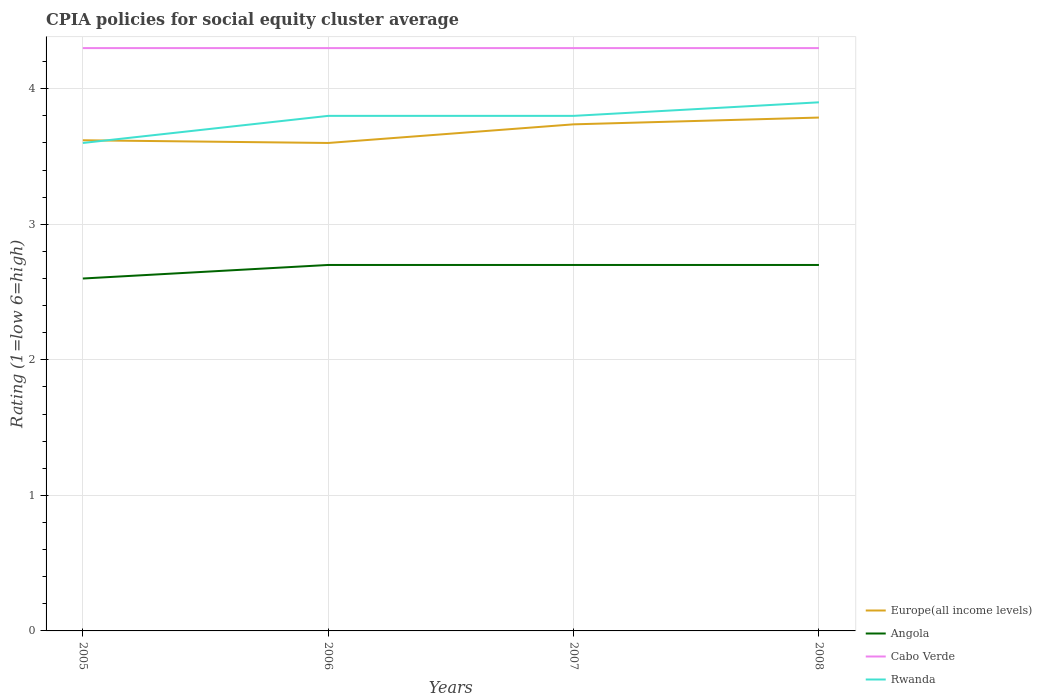How many different coloured lines are there?
Offer a terse response. 4. Is the number of lines equal to the number of legend labels?
Your response must be concise. Yes. Across all years, what is the maximum CPIA rating in Rwanda?
Make the answer very short. 3.6. What is the total CPIA rating in Rwanda in the graph?
Make the answer very short. -0.1. What is the difference between the highest and the lowest CPIA rating in Europe(all income levels)?
Offer a very short reply. 2. Is the CPIA rating in Angola strictly greater than the CPIA rating in Cabo Verde over the years?
Offer a very short reply. Yes. How many lines are there?
Provide a short and direct response. 4. Does the graph contain grids?
Provide a succinct answer. Yes. Where does the legend appear in the graph?
Give a very brief answer. Bottom right. How many legend labels are there?
Keep it short and to the point. 4. How are the legend labels stacked?
Your answer should be compact. Vertical. What is the title of the graph?
Provide a short and direct response. CPIA policies for social equity cluster average. Does "Middle East & North Africa (developing only)" appear as one of the legend labels in the graph?
Offer a terse response. No. What is the label or title of the X-axis?
Offer a very short reply. Years. What is the Rating (1=low 6=high) of Europe(all income levels) in 2005?
Your response must be concise. 3.62. What is the Rating (1=low 6=high) of Rwanda in 2005?
Ensure brevity in your answer.  3.6. What is the Rating (1=low 6=high) of Europe(all income levels) in 2006?
Your answer should be very brief. 3.6. What is the Rating (1=low 6=high) in Angola in 2006?
Provide a short and direct response. 2.7. What is the Rating (1=low 6=high) of Cabo Verde in 2006?
Your answer should be very brief. 4.3. What is the Rating (1=low 6=high) of Europe(all income levels) in 2007?
Keep it short and to the point. 3.74. What is the Rating (1=low 6=high) of Europe(all income levels) in 2008?
Offer a very short reply. 3.79. What is the Rating (1=low 6=high) in Cabo Verde in 2008?
Provide a short and direct response. 4.3. What is the Rating (1=low 6=high) in Rwanda in 2008?
Make the answer very short. 3.9. Across all years, what is the maximum Rating (1=low 6=high) of Europe(all income levels)?
Ensure brevity in your answer.  3.79. Across all years, what is the maximum Rating (1=low 6=high) of Angola?
Your response must be concise. 2.7. Across all years, what is the maximum Rating (1=low 6=high) in Rwanda?
Make the answer very short. 3.9. Across all years, what is the minimum Rating (1=low 6=high) of Europe(all income levels)?
Provide a short and direct response. 3.6. Across all years, what is the minimum Rating (1=low 6=high) in Cabo Verde?
Make the answer very short. 4.3. What is the total Rating (1=low 6=high) in Europe(all income levels) in the graph?
Your answer should be very brief. 14.74. What is the total Rating (1=low 6=high) of Cabo Verde in the graph?
Ensure brevity in your answer.  17.2. What is the total Rating (1=low 6=high) of Rwanda in the graph?
Keep it short and to the point. 15.1. What is the difference between the Rating (1=low 6=high) of Europe(all income levels) in 2005 and that in 2006?
Your answer should be very brief. 0.02. What is the difference between the Rating (1=low 6=high) of Angola in 2005 and that in 2006?
Give a very brief answer. -0.1. What is the difference between the Rating (1=low 6=high) in Cabo Verde in 2005 and that in 2006?
Give a very brief answer. 0. What is the difference between the Rating (1=low 6=high) in Europe(all income levels) in 2005 and that in 2007?
Offer a terse response. -0.12. What is the difference between the Rating (1=low 6=high) of Europe(all income levels) in 2005 and that in 2008?
Offer a very short reply. -0.17. What is the difference between the Rating (1=low 6=high) of Cabo Verde in 2005 and that in 2008?
Provide a succinct answer. 0. What is the difference between the Rating (1=low 6=high) of Rwanda in 2005 and that in 2008?
Provide a succinct answer. -0.3. What is the difference between the Rating (1=low 6=high) of Europe(all income levels) in 2006 and that in 2007?
Your answer should be compact. -0.14. What is the difference between the Rating (1=low 6=high) of Rwanda in 2006 and that in 2007?
Provide a short and direct response. 0. What is the difference between the Rating (1=low 6=high) of Europe(all income levels) in 2006 and that in 2008?
Your response must be concise. -0.19. What is the difference between the Rating (1=low 6=high) in Angola in 2006 and that in 2008?
Provide a short and direct response. 0. What is the difference between the Rating (1=low 6=high) in Cabo Verde in 2006 and that in 2008?
Offer a terse response. 0. What is the difference between the Rating (1=low 6=high) in Rwanda in 2006 and that in 2008?
Offer a terse response. -0.1. What is the difference between the Rating (1=low 6=high) of Europe(all income levels) in 2007 and that in 2008?
Your response must be concise. -0.05. What is the difference between the Rating (1=low 6=high) in Cabo Verde in 2007 and that in 2008?
Ensure brevity in your answer.  0. What is the difference between the Rating (1=low 6=high) of Rwanda in 2007 and that in 2008?
Make the answer very short. -0.1. What is the difference between the Rating (1=low 6=high) in Europe(all income levels) in 2005 and the Rating (1=low 6=high) in Cabo Verde in 2006?
Offer a very short reply. -0.68. What is the difference between the Rating (1=low 6=high) in Europe(all income levels) in 2005 and the Rating (1=low 6=high) in Rwanda in 2006?
Offer a terse response. -0.18. What is the difference between the Rating (1=low 6=high) of Angola in 2005 and the Rating (1=low 6=high) of Rwanda in 2006?
Provide a short and direct response. -1.2. What is the difference between the Rating (1=low 6=high) of Europe(all income levels) in 2005 and the Rating (1=low 6=high) of Cabo Verde in 2007?
Make the answer very short. -0.68. What is the difference between the Rating (1=low 6=high) in Europe(all income levels) in 2005 and the Rating (1=low 6=high) in Rwanda in 2007?
Provide a short and direct response. -0.18. What is the difference between the Rating (1=low 6=high) of Angola in 2005 and the Rating (1=low 6=high) of Rwanda in 2007?
Your response must be concise. -1.2. What is the difference between the Rating (1=low 6=high) of Europe(all income levels) in 2005 and the Rating (1=low 6=high) of Cabo Verde in 2008?
Give a very brief answer. -0.68. What is the difference between the Rating (1=low 6=high) in Europe(all income levels) in 2005 and the Rating (1=low 6=high) in Rwanda in 2008?
Your answer should be very brief. -0.28. What is the difference between the Rating (1=low 6=high) of Cabo Verde in 2005 and the Rating (1=low 6=high) of Rwanda in 2008?
Provide a short and direct response. 0.4. What is the difference between the Rating (1=low 6=high) of Europe(all income levels) in 2006 and the Rating (1=low 6=high) of Angola in 2007?
Offer a terse response. 0.9. What is the difference between the Rating (1=low 6=high) in Europe(all income levels) in 2006 and the Rating (1=low 6=high) in Cabo Verde in 2007?
Give a very brief answer. -0.7. What is the difference between the Rating (1=low 6=high) in Europe(all income levels) in 2006 and the Rating (1=low 6=high) in Rwanda in 2007?
Your response must be concise. -0.2. What is the difference between the Rating (1=low 6=high) of Angola in 2006 and the Rating (1=low 6=high) of Cabo Verde in 2007?
Provide a succinct answer. -1.6. What is the difference between the Rating (1=low 6=high) of Cabo Verde in 2006 and the Rating (1=low 6=high) of Rwanda in 2007?
Give a very brief answer. 0.5. What is the difference between the Rating (1=low 6=high) of Europe(all income levels) in 2006 and the Rating (1=low 6=high) of Angola in 2008?
Your response must be concise. 0.9. What is the difference between the Rating (1=low 6=high) of Europe(all income levels) in 2006 and the Rating (1=low 6=high) of Cabo Verde in 2008?
Keep it short and to the point. -0.7. What is the difference between the Rating (1=low 6=high) of Angola in 2006 and the Rating (1=low 6=high) of Cabo Verde in 2008?
Keep it short and to the point. -1.6. What is the difference between the Rating (1=low 6=high) in Angola in 2006 and the Rating (1=low 6=high) in Rwanda in 2008?
Give a very brief answer. -1.2. What is the difference between the Rating (1=low 6=high) of Europe(all income levels) in 2007 and the Rating (1=low 6=high) of Angola in 2008?
Your response must be concise. 1.04. What is the difference between the Rating (1=low 6=high) in Europe(all income levels) in 2007 and the Rating (1=low 6=high) in Cabo Verde in 2008?
Offer a very short reply. -0.56. What is the difference between the Rating (1=low 6=high) of Europe(all income levels) in 2007 and the Rating (1=low 6=high) of Rwanda in 2008?
Provide a succinct answer. -0.16. What is the difference between the Rating (1=low 6=high) of Cabo Verde in 2007 and the Rating (1=low 6=high) of Rwanda in 2008?
Provide a short and direct response. 0.4. What is the average Rating (1=low 6=high) of Europe(all income levels) per year?
Ensure brevity in your answer.  3.69. What is the average Rating (1=low 6=high) in Angola per year?
Your answer should be compact. 2.67. What is the average Rating (1=low 6=high) of Rwanda per year?
Your answer should be very brief. 3.77. In the year 2005, what is the difference between the Rating (1=low 6=high) in Europe(all income levels) and Rating (1=low 6=high) in Angola?
Give a very brief answer. 1.02. In the year 2005, what is the difference between the Rating (1=low 6=high) in Europe(all income levels) and Rating (1=low 6=high) in Cabo Verde?
Offer a very short reply. -0.68. In the year 2005, what is the difference between the Rating (1=low 6=high) in Angola and Rating (1=low 6=high) in Cabo Verde?
Your response must be concise. -1.7. In the year 2005, what is the difference between the Rating (1=low 6=high) of Cabo Verde and Rating (1=low 6=high) of Rwanda?
Give a very brief answer. 0.7. In the year 2006, what is the difference between the Rating (1=low 6=high) of Europe(all income levels) and Rating (1=low 6=high) of Angola?
Provide a succinct answer. 0.9. In the year 2006, what is the difference between the Rating (1=low 6=high) in Europe(all income levels) and Rating (1=low 6=high) in Rwanda?
Your answer should be very brief. -0.2. In the year 2006, what is the difference between the Rating (1=low 6=high) in Angola and Rating (1=low 6=high) in Rwanda?
Offer a terse response. -1.1. In the year 2006, what is the difference between the Rating (1=low 6=high) of Cabo Verde and Rating (1=low 6=high) of Rwanda?
Ensure brevity in your answer.  0.5. In the year 2007, what is the difference between the Rating (1=low 6=high) of Europe(all income levels) and Rating (1=low 6=high) of Angola?
Offer a very short reply. 1.04. In the year 2007, what is the difference between the Rating (1=low 6=high) of Europe(all income levels) and Rating (1=low 6=high) of Cabo Verde?
Provide a succinct answer. -0.56. In the year 2007, what is the difference between the Rating (1=low 6=high) in Europe(all income levels) and Rating (1=low 6=high) in Rwanda?
Provide a succinct answer. -0.06. In the year 2008, what is the difference between the Rating (1=low 6=high) of Europe(all income levels) and Rating (1=low 6=high) of Angola?
Your answer should be very brief. 1.09. In the year 2008, what is the difference between the Rating (1=low 6=high) in Europe(all income levels) and Rating (1=low 6=high) in Cabo Verde?
Keep it short and to the point. -0.51. In the year 2008, what is the difference between the Rating (1=low 6=high) in Europe(all income levels) and Rating (1=low 6=high) in Rwanda?
Provide a short and direct response. -0.11. What is the ratio of the Rating (1=low 6=high) in Europe(all income levels) in 2005 to that in 2006?
Keep it short and to the point. 1.01. What is the ratio of the Rating (1=low 6=high) of Europe(all income levels) in 2005 to that in 2007?
Provide a short and direct response. 0.97. What is the ratio of the Rating (1=low 6=high) of Cabo Verde in 2005 to that in 2007?
Provide a succinct answer. 1. What is the ratio of the Rating (1=low 6=high) in Europe(all income levels) in 2005 to that in 2008?
Your response must be concise. 0.96. What is the ratio of the Rating (1=low 6=high) in Angola in 2005 to that in 2008?
Offer a very short reply. 0.96. What is the ratio of the Rating (1=low 6=high) in Cabo Verde in 2005 to that in 2008?
Provide a short and direct response. 1. What is the ratio of the Rating (1=low 6=high) of Rwanda in 2005 to that in 2008?
Keep it short and to the point. 0.92. What is the ratio of the Rating (1=low 6=high) of Europe(all income levels) in 2006 to that in 2007?
Provide a succinct answer. 0.96. What is the ratio of the Rating (1=low 6=high) of Angola in 2006 to that in 2007?
Make the answer very short. 1. What is the ratio of the Rating (1=low 6=high) of Cabo Verde in 2006 to that in 2007?
Make the answer very short. 1. What is the ratio of the Rating (1=low 6=high) in Europe(all income levels) in 2006 to that in 2008?
Your answer should be very brief. 0.95. What is the ratio of the Rating (1=low 6=high) of Angola in 2006 to that in 2008?
Provide a succinct answer. 1. What is the ratio of the Rating (1=low 6=high) in Rwanda in 2006 to that in 2008?
Provide a short and direct response. 0.97. What is the ratio of the Rating (1=low 6=high) in Europe(all income levels) in 2007 to that in 2008?
Make the answer very short. 0.99. What is the ratio of the Rating (1=low 6=high) in Cabo Verde in 2007 to that in 2008?
Provide a succinct answer. 1. What is the ratio of the Rating (1=low 6=high) in Rwanda in 2007 to that in 2008?
Ensure brevity in your answer.  0.97. What is the difference between the highest and the second highest Rating (1=low 6=high) of Europe(all income levels)?
Keep it short and to the point. 0.05. What is the difference between the highest and the second highest Rating (1=low 6=high) in Angola?
Offer a very short reply. 0. What is the difference between the highest and the second highest Rating (1=low 6=high) in Cabo Verde?
Ensure brevity in your answer.  0. What is the difference between the highest and the second highest Rating (1=low 6=high) of Rwanda?
Your response must be concise. 0.1. What is the difference between the highest and the lowest Rating (1=low 6=high) of Europe(all income levels)?
Ensure brevity in your answer.  0.19. What is the difference between the highest and the lowest Rating (1=low 6=high) of Cabo Verde?
Your answer should be compact. 0. 